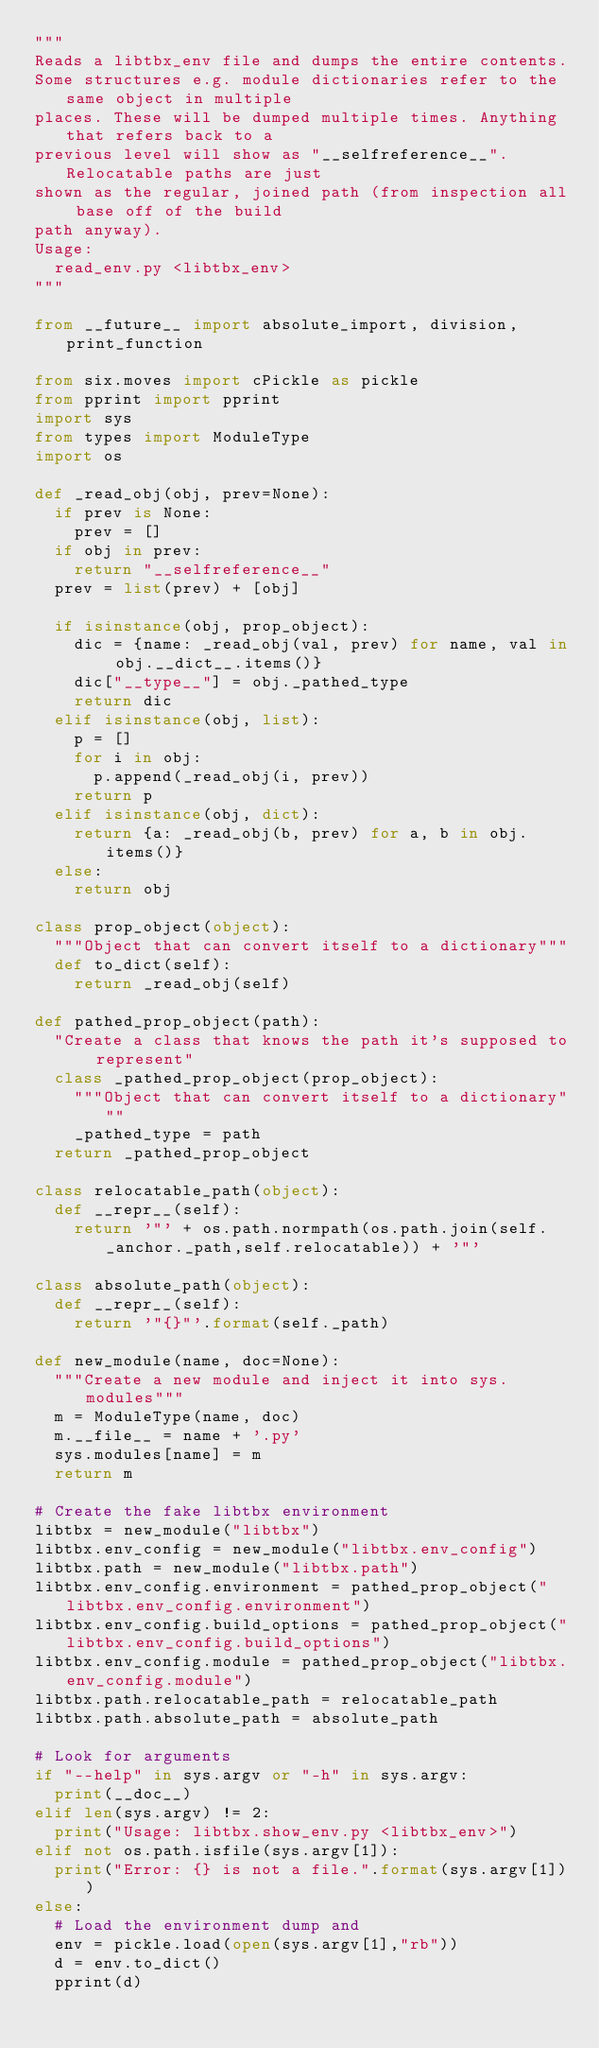<code> <loc_0><loc_0><loc_500><loc_500><_Python_>"""
Reads a libtbx_env file and dumps the entire contents.
Some structures e.g. module dictionaries refer to the same object in multiple
places. These will be dumped multiple times. Anything that refers back to a
previous level will show as "__selfreference__". Relocatable paths are just
shown as the regular, joined path (from inspection all base off of the build
path anyway).
Usage:
  read_env.py <libtbx_env>
"""

from __future__ import absolute_import, division, print_function

from six.moves import cPickle as pickle
from pprint import pprint
import sys
from types import ModuleType
import os

def _read_obj(obj, prev=None):
  if prev is None:
    prev = []
  if obj in prev:
    return "__selfreference__"
  prev = list(prev) + [obj]

  if isinstance(obj, prop_object):
    dic = {name: _read_obj(val, prev) for name, val in obj.__dict__.items()}
    dic["__type__"] = obj._pathed_type
    return dic
  elif isinstance(obj, list):
    p = []
    for i in obj:
      p.append(_read_obj(i, prev))
    return p
  elif isinstance(obj, dict):
    return {a: _read_obj(b, prev) for a, b in obj.items()}
  else:
    return obj

class prop_object(object):
  """Object that can convert itself to a dictionary"""
  def to_dict(self):
    return _read_obj(self)

def pathed_prop_object(path):
  "Create a class that knows the path it's supposed to represent"
  class _pathed_prop_object(prop_object):
    """Object that can convert itself to a dictionary"""
    _pathed_type = path
  return _pathed_prop_object

class relocatable_path(object):
  def __repr__(self):
    return '"' + os.path.normpath(os.path.join(self._anchor._path,self.relocatable)) + '"'

class absolute_path(object):
  def __repr__(self):
    return '"{}"'.format(self._path)

def new_module(name, doc=None):
  """Create a new module and inject it into sys.modules"""
  m = ModuleType(name, doc)
  m.__file__ = name + '.py'
  sys.modules[name] = m
  return m

# Create the fake libtbx environment
libtbx = new_module("libtbx")
libtbx.env_config = new_module("libtbx.env_config")
libtbx.path = new_module("libtbx.path")
libtbx.env_config.environment = pathed_prop_object("libtbx.env_config.environment")
libtbx.env_config.build_options = pathed_prop_object("libtbx.env_config.build_options")
libtbx.env_config.module = pathed_prop_object("libtbx.env_config.module")
libtbx.path.relocatable_path = relocatable_path
libtbx.path.absolute_path = absolute_path

# Look for arguments
if "--help" in sys.argv or "-h" in sys.argv:
  print(__doc__)
elif len(sys.argv) != 2:
  print("Usage: libtbx.show_env.py <libtbx_env>")
elif not os.path.isfile(sys.argv[1]):
  print("Error: {} is not a file.".format(sys.argv[1]))
else:
  # Load the environment dump and
  env = pickle.load(open(sys.argv[1],"rb"))
  d = env.to_dict()
  pprint(d)
</code> 